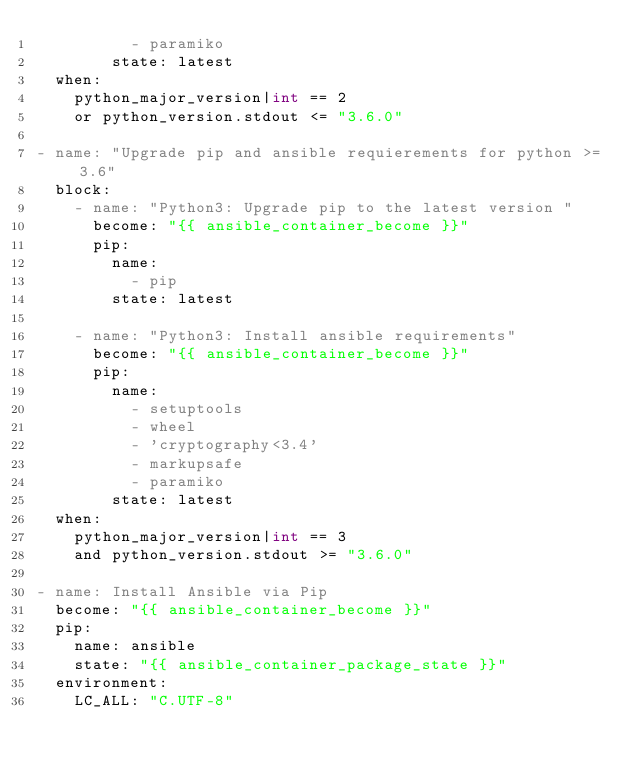Convert code to text. <code><loc_0><loc_0><loc_500><loc_500><_YAML_>          - paramiko
        state: latest
  when:
    python_major_version|int == 2
    or python_version.stdout <= "3.6.0"

- name: "Upgrade pip and ansible requierements for python >= 3.6"
  block:
    - name: "Python3: Upgrade pip to the latest version "
      become: "{{ ansible_container_become }}"
      pip:
        name:
          - pip
        state: latest

    - name: "Python3: Install ansible requirements"
      become: "{{ ansible_container_become }}"
      pip:
        name:
          - setuptools
          - wheel
          - 'cryptography<3.4'
          - markupsafe
          - paramiko
        state: latest
  when:
    python_major_version|int == 3
    and python_version.stdout >= "3.6.0"

- name: Install Ansible via Pip
  become: "{{ ansible_container_become }}"
  pip:
    name: ansible
    state: "{{ ansible_container_package_state }}"
  environment:
    LC_ALL: "C.UTF-8"
</code> 